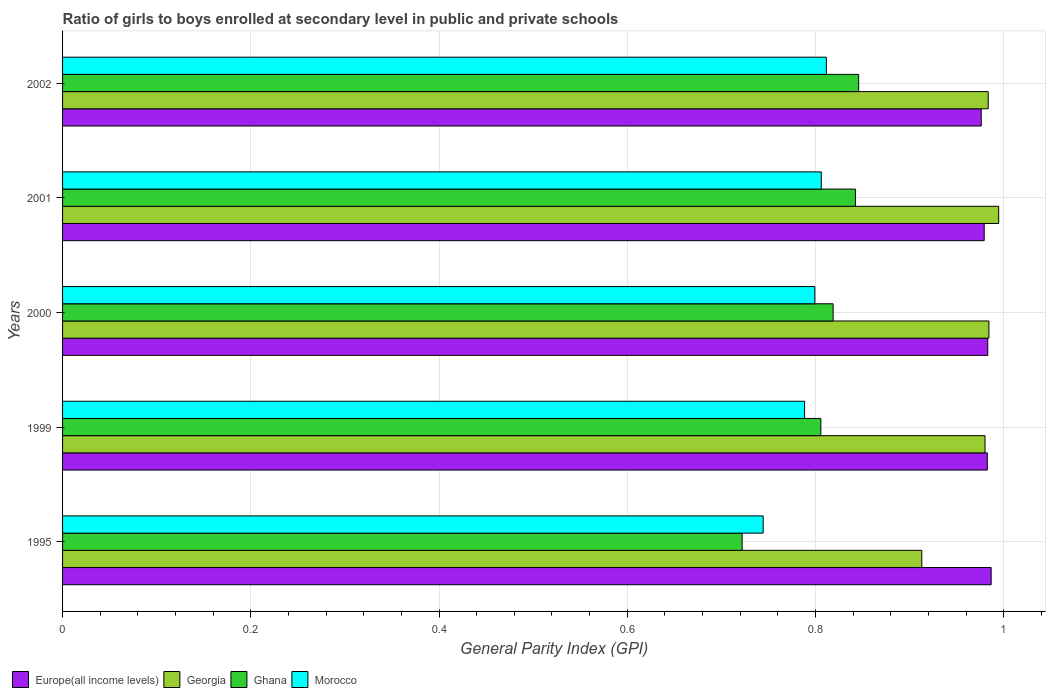How many different coloured bars are there?
Your response must be concise. 4. How many groups of bars are there?
Provide a succinct answer. 5. How many bars are there on the 3rd tick from the top?
Your response must be concise. 4. How many bars are there on the 1st tick from the bottom?
Your response must be concise. 4. In how many cases, is the number of bars for a given year not equal to the number of legend labels?
Provide a succinct answer. 0. What is the general parity index in Georgia in 1999?
Your response must be concise. 0.98. Across all years, what is the maximum general parity index in Europe(all income levels)?
Make the answer very short. 0.99. Across all years, what is the minimum general parity index in Georgia?
Offer a terse response. 0.91. What is the total general parity index in Morocco in the graph?
Provide a short and direct response. 3.95. What is the difference between the general parity index in Europe(all income levels) in 1995 and that in 2000?
Your answer should be very brief. 0. What is the difference between the general parity index in Morocco in 1995 and the general parity index in Ghana in 2002?
Your answer should be very brief. -0.1. What is the average general parity index in Morocco per year?
Keep it short and to the point. 0.79. In the year 2000, what is the difference between the general parity index in Morocco and general parity index in Georgia?
Your answer should be compact. -0.18. What is the ratio of the general parity index in Europe(all income levels) in 1995 to that in 2000?
Offer a terse response. 1. What is the difference between the highest and the second highest general parity index in Europe(all income levels)?
Provide a succinct answer. 0. What is the difference between the highest and the lowest general parity index in Ghana?
Offer a very short reply. 0.12. Is the sum of the general parity index in Ghana in 2000 and 2001 greater than the maximum general parity index in Georgia across all years?
Give a very brief answer. Yes. What does the 1st bar from the top in 1999 represents?
Offer a very short reply. Morocco. What does the 1st bar from the bottom in 1999 represents?
Your answer should be very brief. Europe(all income levels). How many years are there in the graph?
Keep it short and to the point. 5. Where does the legend appear in the graph?
Provide a succinct answer. Bottom left. How many legend labels are there?
Make the answer very short. 4. How are the legend labels stacked?
Your answer should be compact. Horizontal. What is the title of the graph?
Provide a short and direct response. Ratio of girls to boys enrolled at secondary level in public and private schools. Does "Germany" appear as one of the legend labels in the graph?
Provide a short and direct response. No. What is the label or title of the X-axis?
Your answer should be compact. General Parity Index (GPI). What is the General Parity Index (GPI) in Europe(all income levels) in 1995?
Make the answer very short. 0.99. What is the General Parity Index (GPI) of Georgia in 1995?
Give a very brief answer. 0.91. What is the General Parity Index (GPI) of Ghana in 1995?
Your response must be concise. 0.72. What is the General Parity Index (GPI) of Morocco in 1995?
Your answer should be compact. 0.74. What is the General Parity Index (GPI) in Europe(all income levels) in 1999?
Ensure brevity in your answer.  0.98. What is the General Parity Index (GPI) of Georgia in 1999?
Make the answer very short. 0.98. What is the General Parity Index (GPI) in Ghana in 1999?
Offer a very short reply. 0.81. What is the General Parity Index (GPI) in Morocco in 1999?
Provide a succinct answer. 0.79. What is the General Parity Index (GPI) of Europe(all income levels) in 2000?
Provide a succinct answer. 0.98. What is the General Parity Index (GPI) of Georgia in 2000?
Give a very brief answer. 0.98. What is the General Parity Index (GPI) in Ghana in 2000?
Keep it short and to the point. 0.82. What is the General Parity Index (GPI) in Morocco in 2000?
Make the answer very short. 0.8. What is the General Parity Index (GPI) of Europe(all income levels) in 2001?
Keep it short and to the point. 0.98. What is the General Parity Index (GPI) in Georgia in 2001?
Offer a terse response. 0.99. What is the General Parity Index (GPI) in Ghana in 2001?
Your answer should be compact. 0.84. What is the General Parity Index (GPI) in Morocco in 2001?
Give a very brief answer. 0.81. What is the General Parity Index (GPI) of Europe(all income levels) in 2002?
Give a very brief answer. 0.98. What is the General Parity Index (GPI) in Georgia in 2002?
Give a very brief answer. 0.98. What is the General Parity Index (GPI) in Ghana in 2002?
Provide a succinct answer. 0.85. What is the General Parity Index (GPI) in Morocco in 2002?
Your response must be concise. 0.81. Across all years, what is the maximum General Parity Index (GPI) of Europe(all income levels)?
Your answer should be very brief. 0.99. Across all years, what is the maximum General Parity Index (GPI) of Georgia?
Ensure brevity in your answer.  0.99. Across all years, what is the maximum General Parity Index (GPI) in Ghana?
Provide a succinct answer. 0.85. Across all years, what is the maximum General Parity Index (GPI) of Morocco?
Offer a terse response. 0.81. Across all years, what is the minimum General Parity Index (GPI) of Europe(all income levels)?
Your answer should be very brief. 0.98. Across all years, what is the minimum General Parity Index (GPI) of Georgia?
Offer a terse response. 0.91. Across all years, what is the minimum General Parity Index (GPI) of Ghana?
Your response must be concise. 0.72. Across all years, what is the minimum General Parity Index (GPI) of Morocco?
Keep it short and to the point. 0.74. What is the total General Parity Index (GPI) of Europe(all income levels) in the graph?
Provide a succinct answer. 4.91. What is the total General Parity Index (GPI) of Georgia in the graph?
Your answer should be very brief. 4.86. What is the total General Parity Index (GPI) of Ghana in the graph?
Keep it short and to the point. 4.03. What is the total General Parity Index (GPI) in Morocco in the graph?
Give a very brief answer. 3.95. What is the difference between the General Parity Index (GPI) in Europe(all income levels) in 1995 and that in 1999?
Ensure brevity in your answer.  0. What is the difference between the General Parity Index (GPI) of Georgia in 1995 and that in 1999?
Your answer should be very brief. -0.07. What is the difference between the General Parity Index (GPI) in Ghana in 1995 and that in 1999?
Your answer should be very brief. -0.08. What is the difference between the General Parity Index (GPI) in Morocco in 1995 and that in 1999?
Give a very brief answer. -0.04. What is the difference between the General Parity Index (GPI) of Europe(all income levels) in 1995 and that in 2000?
Provide a succinct answer. 0. What is the difference between the General Parity Index (GPI) of Georgia in 1995 and that in 2000?
Your answer should be very brief. -0.07. What is the difference between the General Parity Index (GPI) in Ghana in 1995 and that in 2000?
Provide a succinct answer. -0.1. What is the difference between the General Parity Index (GPI) in Morocco in 1995 and that in 2000?
Provide a succinct answer. -0.05. What is the difference between the General Parity Index (GPI) of Europe(all income levels) in 1995 and that in 2001?
Keep it short and to the point. 0.01. What is the difference between the General Parity Index (GPI) of Georgia in 1995 and that in 2001?
Make the answer very short. -0.08. What is the difference between the General Parity Index (GPI) in Ghana in 1995 and that in 2001?
Give a very brief answer. -0.12. What is the difference between the General Parity Index (GPI) in Morocco in 1995 and that in 2001?
Keep it short and to the point. -0.06. What is the difference between the General Parity Index (GPI) of Europe(all income levels) in 1995 and that in 2002?
Offer a terse response. 0.01. What is the difference between the General Parity Index (GPI) in Georgia in 1995 and that in 2002?
Ensure brevity in your answer.  -0.07. What is the difference between the General Parity Index (GPI) in Ghana in 1995 and that in 2002?
Offer a terse response. -0.12. What is the difference between the General Parity Index (GPI) in Morocco in 1995 and that in 2002?
Provide a succinct answer. -0.07. What is the difference between the General Parity Index (GPI) of Europe(all income levels) in 1999 and that in 2000?
Your answer should be very brief. -0. What is the difference between the General Parity Index (GPI) of Georgia in 1999 and that in 2000?
Your answer should be compact. -0. What is the difference between the General Parity Index (GPI) of Ghana in 1999 and that in 2000?
Give a very brief answer. -0.01. What is the difference between the General Parity Index (GPI) in Morocco in 1999 and that in 2000?
Your answer should be compact. -0.01. What is the difference between the General Parity Index (GPI) in Europe(all income levels) in 1999 and that in 2001?
Give a very brief answer. 0. What is the difference between the General Parity Index (GPI) of Georgia in 1999 and that in 2001?
Your answer should be very brief. -0.01. What is the difference between the General Parity Index (GPI) of Ghana in 1999 and that in 2001?
Provide a short and direct response. -0.04. What is the difference between the General Parity Index (GPI) of Morocco in 1999 and that in 2001?
Give a very brief answer. -0.02. What is the difference between the General Parity Index (GPI) of Europe(all income levels) in 1999 and that in 2002?
Provide a short and direct response. 0.01. What is the difference between the General Parity Index (GPI) of Georgia in 1999 and that in 2002?
Keep it short and to the point. -0. What is the difference between the General Parity Index (GPI) in Ghana in 1999 and that in 2002?
Ensure brevity in your answer.  -0.04. What is the difference between the General Parity Index (GPI) in Morocco in 1999 and that in 2002?
Provide a short and direct response. -0.02. What is the difference between the General Parity Index (GPI) of Europe(all income levels) in 2000 and that in 2001?
Your answer should be very brief. 0. What is the difference between the General Parity Index (GPI) in Georgia in 2000 and that in 2001?
Keep it short and to the point. -0.01. What is the difference between the General Parity Index (GPI) in Ghana in 2000 and that in 2001?
Give a very brief answer. -0.02. What is the difference between the General Parity Index (GPI) in Morocco in 2000 and that in 2001?
Ensure brevity in your answer.  -0.01. What is the difference between the General Parity Index (GPI) in Europe(all income levels) in 2000 and that in 2002?
Keep it short and to the point. 0.01. What is the difference between the General Parity Index (GPI) in Georgia in 2000 and that in 2002?
Make the answer very short. 0. What is the difference between the General Parity Index (GPI) of Ghana in 2000 and that in 2002?
Provide a succinct answer. -0.03. What is the difference between the General Parity Index (GPI) in Morocco in 2000 and that in 2002?
Provide a short and direct response. -0.01. What is the difference between the General Parity Index (GPI) in Europe(all income levels) in 2001 and that in 2002?
Provide a succinct answer. 0. What is the difference between the General Parity Index (GPI) of Georgia in 2001 and that in 2002?
Provide a succinct answer. 0.01. What is the difference between the General Parity Index (GPI) in Ghana in 2001 and that in 2002?
Your answer should be very brief. -0. What is the difference between the General Parity Index (GPI) in Morocco in 2001 and that in 2002?
Provide a succinct answer. -0.01. What is the difference between the General Parity Index (GPI) of Europe(all income levels) in 1995 and the General Parity Index (GPI) of Georgia in 1999?
Your answer should be very brief. 0.01. What is the difference between the General Parity Index (GPI) in Europe(all income levels) in 1995 and the General Parity Index (GPI) in Ghana in 1999?
Offer a very short reply. 0.18. What is the difference between the General Parity Index (GPI) in Europe(all income levels) in 1995 and the General Parity Index (GPI) in Morocco in 1999?
Offer a terse response. 0.2. What is the difference between the General Parity Index (GPI) in Georgia in 1995 and the General Parity Index (GPI) in Ghana in 1999?
Give a very brief answer. 0.11. What is the difference between the General Parity Index (GPI) in Georgia in 1995 and the General Parity Index (GPI) in Morocco in 1999?
Provide a short and direct response. 0.12. What is the difference between the General Parity Index (GPI) of Ghana in 1995 and the General Parity Index (GPI) of Morocco in 1999?
Provide a short and direct response. -0.07. What is the difference between the General Parity Index (GPI) in Europe(all income levels) in 1995 and the General Parity Index (GPI) in Georgia in 2000?
Give a very brief answer. 0. What is the difference between the General Parity Index (GPI) of Europe(all income levels) in 1995 and the General Parity Index (GPI) of Ghana in 2000?
Give a very brief answer. 0.17. What is the difference between the General Parity Index (GPI) of Europe(all income levels) in 1995 and the General Parity Index (GPI) of Morocco in 2000?
Keep it short and to the point. 0.19. What is the difference between the General Parity Index (GPI) of Georgia in 1995 and the General Parity Index (GPI) of Ghana in 2000?
Provide a succinct answer. 0.09. What is the difference between the General Parity Index (GPI) in Georgia in 1995 and the General Parity Index (GPI) in Morocco in 2000?
Make the answer very short. 0.11. What is the difference between the General Parity Index (GPI) in Ghana in 1995 and the General Parity Index (GPI) in Morocco in 2000?
Offer a very short reply. -0.08. What is the difference between the General Parity Index (GPI) of Europe(all income levels) in 1995 and the General Parity Index (GPI) of Georgia in 2001?
Give a very brief answer. -0.01. What is the difference between the General Parity Index (GPI) in Europe(all income levels) in 1995 and the General Parity Index (GPI) in Ghana in 2001?
Make the answer very short. 0.14. What is the difference between the General Parity Index (GPI) in Europe(all income levels) in 1995 and the General Parity Index (GPI) in Morocco in 2001?
Make the answer very short. 0.18. What is the difference between the General Parity Index (GPI) in Georgia in 1995 and the General Parity Index (GPI) in Ghana in 2001?
Your answer should be very brief. 0.07. What is the difference between the General Parity Index (GPI) of Georgia in 1995 and the General Parity Index (GPI) of Morocco in 2001?
Offer a very short reply. 0.11. What is the difference between the General Parity Index (GPI) in Ghana in 1995 and the General Parity Index (GPI) in Morocco in 2001?
Give a very brief answer. -0.08. What is the difference between the General Parity Index (GPI) of Europe(all income levels) in 1995 and the General Parity Index (GPI) of Georgia in 2002?
Ensure brevity in your answer.  0. What is the difference between the General Parity Index (GPI) in Europe(all income levels) in 1995 and the General Parity Index (GPI) in Ghana in 2002?
Your response must be concise. 0.14. What is the difference between the General Parity Index (GPI) in Europe(all income levels) in 1995 and the General Parity Index (GPI) in Morocco in 2002?
Your answer should be very brief. 0.18. What is the difference between the General Parity Index (GPI) in Georgia in 1995 and the General Parity Index (GPI) in Ghana in 2002?
Offer a very short reply. 0.07. What is the difference between the General Parity Index (GPI) of Georgia in 1995 and the General Parity Index (GPI) of Morocco in 2002?
Your response must be concise. 0.1. What is the difference between the General Parity Index (GPI) in Ghana in 1995 and the General Parity Index (GPI) in Morocco in 2002?
Offer a very short reply. -0.09. What is the difference between the General Parity Index (GPI) in Europe(all income levels) in 1999 and the General Parity Index (GPI) in Georgia in 2000?
Offer a terse response. -0. What is the difference between the General Parity Index (GPI) in Europe(all income levels) in 1999 and the General Parity Index (GPI) in Ghana in 2000?
Your answer should be compact. 0.16. What is the difference between the General Parity Index (GPI) of Europe(all income levels) in 1999 and the General Parity Index (GPI) of Morocco in 2000?
Make the answer very short. 0.18. What is the difference between the General Parity Index (GPI) of Georgia in 1999 and the General Parity Index (GPI) of Ghana in 2000?
Your answer should be very brief. 0.16. What is the difference between the General Parity Index (GPI) of Georgia in 1999 and the General Parity Index (GPI) of Morocco in 2000?
Make the answer very short. 0.18. What is the difference between the General Parity Index (GPI) in Ghana in 1999 and the General Parity Index (GPI) in Morocco in 2000?
Offer a very short reply. 0.01. What is the difference between the General Parity Index (GPI) of Europe(all income levels) in 1999 and the General Parity Index (GPI) of Georgia in 2001?
Keep it short and to the point. -0.01. What is the difference between the General Parity Index (GPI) of Europe(all income levels) in 1999 and the General Parity Index (GPI) of Ghana in 2001?
Your answer should be very brief. 0.14. What is the difference between the General Parity Index (GPI) in Europe(all income levels) in 1999 and the General Parity Index (GPI) in Morocco in 2001?
Keep it short and to the point. 0.18. What is the difference between the General Parity Index (GPI) in Georgia in 1999 and the General Parity Index (GPI) in Ghana in 2001?
Give a very brief answer. 0.14. What is the difference between the General Parity Index (GPI) in Georgia in 1999 and the General Parity Index (GPI) in Morocco in 2001?
Provide a short and direct response. 0.17. What is the difference between the General Parity Index (GPI) of Ghana in 1999 and the General Parity Index (GPI) of Morocco in 2001?
Provide a short and direct response. -0. What is the difference between the General Parity Index (GPI) of Europe(all income levels) in 1999 and the General Parity Index (GPI) of Georgia in 2002?
Your answer should be very brief. -0. What is the difference between the General Parity Index (GPI) in Europe(all income levels) in 1999 and the General Parity Index (GPI) in Ghana in 2002?
Make the answer very short. 0.14. What is the difference between the General Parity Index (GPI) of Europe(all income levels) in 1999 and the General Parity Index (GPI) of Morocco in 2002?
Make the answer very short. 0.17. What is the difference between the General Parity Index (GPI) of Georgia in 1999 and the General Parity Index (GPI) of Ghana in 2002?
Provide a succinct answer. 0.13. What is the difference between the General Parity Index (GPI) of Georgia in 1999 and the General Parity Index (GPI) of Morocco in 2002?
Your answer should be compact. 0.17. What is the difference between the General Parity Index (GPI) in Ghana in 1999 and the General Parity Index (GPI) in Morocco in 2002?
Give a very brief answer. -0.01. What is the difference between the General Parity Index (GPI) of Europe(all income levels) in 2000 and the General Parity Index (GPI) of Georgia in 2001?
Provide a succinct answer. -0.01. What is the difference between the General Parity Index (GPI) in Europe(all income levels) in 2000 and the General Parity Index (GPI) in Ghana in 2001?
Provide a succinct answer. 0.14. What is the difference between the General Parity Index (GPI) of Europe(all income levels) in 2000 and the General Parity Index (GPI) of Morocco in 2001?
Keep it short and to the point. 0.18. What is the difference between the General Parity Index (GPI) of Georgia in 2000 and the General Parity Index (GPI) of Ghana in 2001?
Provide a succinct answer. 0.14. What is the difference between the General Parity Index (GPI) in Georgia in 2000 and the General Parity Index (GPI) in Morocco in 2001?
Ensure brevity in your answer.  0.18. What is the difference between the General Parity Index (GPI) in Ghana in 2000 and the General Parity Index (GPI) in Morocco in 2001?
Provide a succinct answer. 0.01. What is the difference between the General Parity Index (GPI) of Europe(all income levels) in 2000 and the General Parity Index (GPI) of Georgia in 2002?
Your answer should be compact. -0. What is the difference between the General Parity Index (GPI) of Europe(all income levels) in 2000 and the General Parity Index (GPI) of Ghana in 2002?
Provide a succinct answer. 0.14. What is the difference between the General Parity Index (GPI) in Europe(all income levels) in 2000 and the General Parity Index (GPI) in Morocco in 2002?
Give a very brief answer. 0.17. What is the difference between the General Parity Index (GPI) in Georgia in 2000 and the General Parity Index (GPI) in Ghana in 2002?
Make the answer very short. 0.14. What is the difference between the General Parity Index (GPI) of Georgia in 2000 and the General Parity Index (GPI) of Morocco in 2002?
Keep it short and to the point. 0.17. What is the difference between the General Parity Index (GPI) in Ghana in 2000 and the General Parity Index (GPI) in Morocco in 2002?
Ensure brevity in your answer.  0.01. What is the difference between the General Parity Index (GPI) in Europe(all income levels) in 2001 and the General Parity Index (GPI) in Georgia in 2002?
Offer a very short reply. -0. What is the difference between the General Parity Index (GPI) in Europe(all income levels) in 2001 and the General Parity Index (GPI) in Ghana in 2002?
Ensure brevity in your answer.  0.13. What is the difference between the General Parity Index (GPI) of Europe(all income levels) in 2001 and the General Parity Index (GPI) of Morocco in 2002?
Keep it short and to the point. 0.17. What is the difference between the General Parity Index (GPI) of Georgia in 2001 and the General Parity Index (GPI) of Ghana in 2002?
Provide a short and direct response. 0.15. What is the difference between the General Parity Index (GPI) of Georgia in 2001 and the General Parity Index (GPI) of Morocco in 2002?
Your answer should be compact. 0.18. What is the difference between the General Parity Index (GPI) of Ghana in 2001 and the General Parity Index (GPI) of Morocco in 2002?
Your answer should be compact. 0.03. What is the average General Parity Index (GPI) of Europe(all income levels) per year?
Your response must be concise. 0.98. What is the average General Parity Index (GPI) in Georgia per year?
Give a very brief answer. 0.97. What is the average General Parity Index (GPI) of Ghana per year?
Your response must be concise. 0.81. What is the average General Parity Index (GPI) of Morocco per year?
Offer a terse response. 0.79. In the year 1995, what is the difference between the General Parity Index (GPI) of Europe(all income levels) and General Parity Index (GPI) of Georgia?
Provide a short and direct response. 0.07. In the year 1995, what is the difference between the General Parity Index (GPI) in Europe(all income levels) and General Parity Index (GPI) in Ghana?
Your answer should be very brief. 0.26. In the year 1995, what is the difference between the General Parity Index (GPI) of Europe(all income levels) and General Parity Index (GPI) of Morocco?
Offer a terse response. 0.24. In the year 1995, what is the difference between the General Parity Index (GPI) in Georgia and General Parity Index (GPI) in Ghana?
Provide a short and direct response. 0.19. In the year 1995, what is the difference between the General Parity Index (GPI) in Georgia and General Parity Index (GPI) in Morocco?
Ensure brevity in your answer.  0.17. In the year 1995, what is the difference between the General Parity Index (GPI) of Ghana and General Parity Index (GPI) of Morocco?
Give a very brief answer. -0.02. In the year 1999, what is the difference between the General Parity Index (GPI) in Europe(all income levels) and General Parity Index (GPI) in Georgia?
Ensure brevity in your answer.  0. In the year 1999, what is the difference between the General Parity Index (GPI) in Europe(all income levels) and General Parity Index (GPI) in Ghana?
Make the answer very short. 0.18. In the year 1999, what is the difference between the General Parity Index (GPI) in Europe(all income levels) and General Parity Index (GPI) in Morocco?
Offer a very short reply. 0.19. In the year 1999, what is the difference between the General Parity Index (GPI) in Georgia and General Parity Index (GPI) in Ghana?
Provide a succinct answer. 0.17. In the year 1999, what is the difference between the General Parity Index (GPI) in Georgia and General Parity Index (GPI) in Morocco?
Make the answer very short. 0.19. In the year 1999, what is the difference between the General Parity Index (GPI) of Ghana and General Parity Index (GPI) of Morocco?
Your response must be concise. 0.02. In the year 2000, what is the difference between the General Parity Index (GPI) in Europe(all income levels) and General Parity Index (GPI) in Georgia?
Ensure brevity in your answer.  -0. In the year 2000, what is the difference between the General Parity Index (GPI) in Europe(all income levels) and General Parity Index (GPI) in Ghana?
Offer a very short reply. 0.16. In the year 2000, what is the difference between the General Parity Index (GPI) in Europe(all income levels) and General Parity Index (GPI) in Morocco?
Offer a terse response. 0.18. In the year 2000, what is the difference between the General Parity Index (GPI) of Georgia and General Parity Index (GPI) of Ghana?
Offer a very short reply. 0.17. In the year 2000, what is the difference between the General Parity Index (GPI) of Georgia and General Parity Index (GPI) of Morocco?
Your answer should be very brief. 0.18. In the year 2000, what is the difference between the General Parity Index (GPI) in Ghana and General Parity Index (GPI) in Morocco?
Your answer should be compact. 0.02. In the year 2001, what is the difference between the General Parity Index (GPI) in Europe(all income levels) and General Parity Index (GPI) in Georgia?
Provide a succinct answer. -0.02. In the year 2001, what is the difference between the General Parity Index (GPI) of Europe(all income levels) and General Parity Index (GPI) of Ghana?
Your answer should be very brief. 0.14. In the year 2001, what is the difference between the General Parity Index (GPI) in Europe(all income levels) and General Parity Index (GPI) in Morocco?
Make the answer very short. 0.17. In the year 2001, what is the difference between the General Parity Index (GPI) in Georgia and General Parity Index (GPI) in Ghana?
Offer a very short reply. 0.15. In the year 2001, what is the difference between the General Parity Index (GPI) of Georgia and General Parity Index (GPI) of Morocco?
Provide a succinct answer. 0.19. In the year 2001, what is the difference between the General Parity Index (GPI) of Ghana and General Parity Index (GPI) of Morocco?
Provide a succinct answer. 0.04. In the year 2002, what is the difference between the General Parity Index (GPI) of Europe(all income levels) and General Parity Index (GPI) of Georgia?
Offer a very short reply. -0.01. In the year 2002, what is the difference between the General Parity Index (GPI) of Europe(all income levels) and General Parity Index (GPI) of Ghana?
Provide a short and direct response. 0.13. In the year 2002, what is the difference between the General Parity Index (GPI) of Europe(all income levels) and General Parity Index (GPI) of Morocco?
Offer a terse response. 0.16. In the year 2002, what is the difference between the General Parity Index (GPI) of Georgia and General Parity Index (GPI) of Ghana?
Offer a terse response. 0.14. In the year 2002, what is the difference between the General Parity Index (GPI) in Georgia and General Parity Index (GPI) in Morocco?
Ensure brevity in your answer.  0.17. In the year 2002, what is the difference between the General Parity Index (GPI) of Ghana and General Parity Index (GPI) of Morocco?
Your response must be concise. 0.03. What is the ratio of the General Parity Index (GPI) in Europe(all income levels) in 1995 to that in 1999?
Give a very brief answer. 1. What is the ratio of the General Parity Index (GPI) of Georgia in 1995 to that in 1999?
Offer a terse response. 0.93. What is the ratio of the General Parity Index (GPI) in Ghana in 1995 to that in 1999?
Your answer should be very brief. 0.9. What is the ratio of the General Parity Index (GPI) of Morocco in 1995 to that in 1999?
Keep it short and to the point. 0.94. What is the ratio of the General Parity Index (GPI) in Georgia in 1995 to that in 2000?
Provide a short and direct response. 0.93. What is the ratio of the General Parity Index (GPI) of Ghana in 1995 to that in 2000?
Your answer should be very brief. 0.88. What is the ratio of the General Parity Index (GPI) of Morocco in 1995 to that in 2000?
Keep it short and to the point. 0.93. What is the ratio of the General Parity Index (GPI) in Europe(all income levels) in 1995 to that in 2001?
Provide a short and direct response. 1.01. What is the ratio of the General Parity Index (GPI) in Georgia in 1995 to that in 2001?
Give a very brief answer. 0.92. What is the ratio of the General Parity Index (GPI) of Ghana in 1995 to that in 2001?
Give a very brief answer. 0.86. What is the ratio of the General Parity Index (GPI) of Morocco in 1995 to that in 2001?
Offer a terse response. 0.92. What is the ratio of the General Parity Index (GPI) in Europe(all income levels) in 1995 to that in 2002?
Ensure brevity in your answer.  1.01. What is the ratio of the General Parity Index (GPI) of Georgia in 1995 to that in 2002?
Your answer should be very brief. 0.93. What is the ratio of the General Parity Index (GPI) of Ghana in 1995 to that in 2002?
Provide a short and direct response. 0.85. What is the ratio of the General Parity Index (GPI) in Morocco in 1995 to that in 2002?
Make the answer very short. 0.92. What is the ratio of the General Parity Index (GPI) of Ghana in 1999 to that in 2000?
Your answer should be very brief. 0.98. What is the ratio of the General Parity Index (GPI) in Morocco in 1999 to that in 2000?
Provide a short and direct response. 0.99. What is the ratio of the General Parity Index (GPI) in Europe(all income levels) in 1999 to that in 2001?
Make the answer very short. 1. What is the ratio of the General Parity Index (GPI) of Georgia in 1999 to that in 2001?
Offer a terse response. 0.99. What is the ratio of the General Parity Index (GPI) of Ghana in 1999 to that in 2001?
Your response must be concise. 0.96. What is the ratio of the General Parity Index (GPI) in Morocco in 1999 to that in 2001?
Offer a terse response. 0.98. What is the ratio of the General Parity Index (GPI) of Europe(all income levels) in 1999 to that in 2002?
Make the answer very short. 1.01. What is the ratio of the General Parity Index (GPI) of Ghana in 1999 to that in 2002?
Your response must be concise. 0.95. What is the ratio of the General Parity Index (GPI) of Morocco in 1999 to that in 2002?
Your response must be concise. 0.97. What is the ratio of the General Parity Index (GPI) in Europe(all income levels) in 2000 to that in 2001?
Offer a terse response. 1. What is the ratio of the General Parity Index (GPI) of Ghana in 2000 to that in 2001?
Provide a short and direct response. 0.97. What is the ratio of the General Parity Index (GPI) of Europe(all income levels) in 2000 to that in 2002?
Ensure brevity in your answer.  1.01. What is the ratio of the General Parity Index (GPI) of Ghana in 2000 to that in 2002?
Offer a terse response. 0.97. What is the ratio of the General Parity Index (GPI) in Morocco in 2000 to that in 2002?
Provide a short and direct response. 0.98. What is the ratio of the General Parity Index (GPI) in Georgia in 2001 to that in 2002?
Offer a very short reply. 1.01. What is the difference between the highest and the second highest General Parity Index (GPI) in Europe(all income levels)?
Ensure brevity in your answer.  0. What is the difference between the highest and the second highest General Parity Index (GPI) of Georgia?
Keep it short and to the point. 0.01. What is the difference between the highest and the second highest General Parity Index (GPI) of Ghana?
Provide a succinct answer. 0. What is the difference between the highest and the second highest General Parity Index (GPI) of Morocco?
Provide a short and direct response. 0.01. What is the difference between the highest and the lowest General Parity Index (GPI) of Europe(all income levels)?
Ensure brevity in your answer.  0.01. What is the difference between the highest and the lowest General Parity Index (GPI) in Georgia?
Offer a very short reply. 0.08. What is the difference between the highest and the lowest General Parity Index (GPI) in Ghana?
Provide a short and direct response. 0.12. What is the difference between the highest and the lowest General Parity Index (GPI) of Morocco?
Your response must be concise. 0.07. 